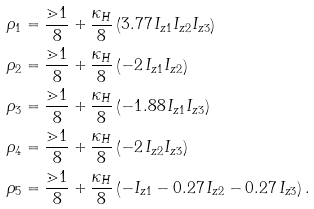Convert formula to latex. <formula><loc_0><loc_0><loc_500><loc_500>\rho _ { 1 } & = \frac { \mathbb { m } { 1 } } { 8 } + \frac { \kappa _ { H } } { 8 } \left ( 3 . 7 7 \, I _ { z 1 } I _ { z 2 } I _ { z 3 } \right ) \\ \rho _ { 2 } & = \frac { \mathbb { m } { 1 } } { 8 } + \frac { \kappa _ { H } } { 8 } \left ( - 2 \, I _ { z 1 } I _ { z 2 } \right ) \\ \rho _ { 3 } & = \frac { \mathbb { m } { 1 } } { 8 } + \frac { \kappa _ { H } } { 8 } \left ( - 1 . 8 8 \, I _ { z 1 } I _ { z 3 } \right ) \\ \rho _ { 4 } & = \frac { \mathbb { m } { 1 } } { 8 } + \frac { \kappa _ { H } } { 8 } \left ( - 2 \, I _ { z 2 } I _ { z 3 } \right ) \\ \rho _ { 5 } & = \frac { \mathbb { m } { 1 } } { 8 } + \frac { \kappa _ { H } } { 8 } \left ( - I _ { z 1 } - 0 . 2 7 \, I _ { z 2 } - 0 . 2 7 \, I _ { z 3 } \right ) .</formula> 